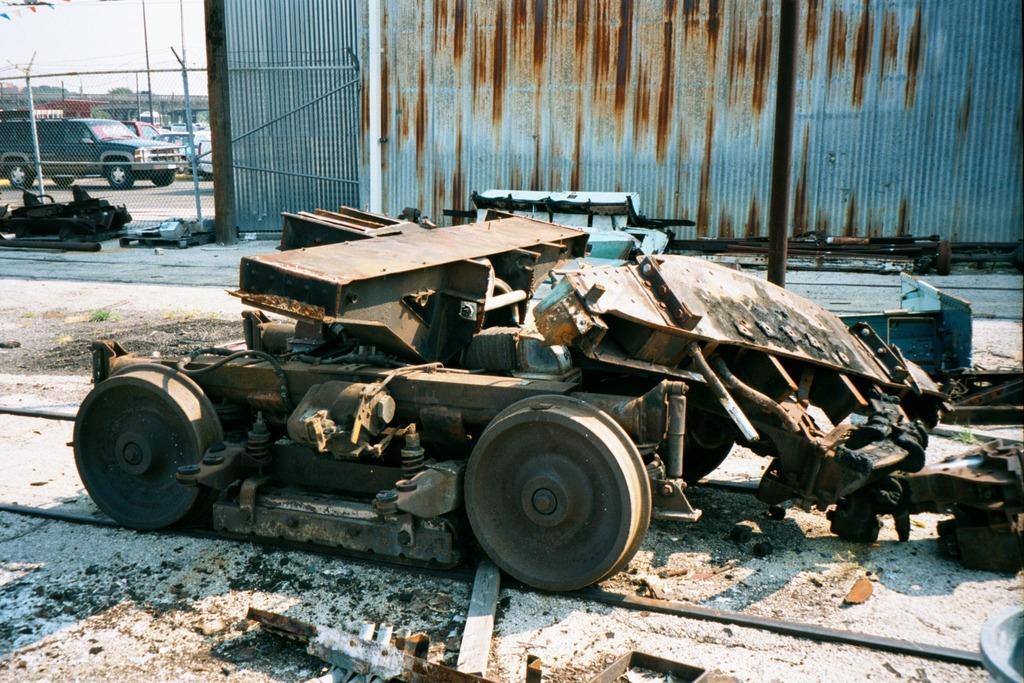Please provide a concise description of this image. In this picture we can see a vehicle and few objects on the ground and in the background we can see a fence, wall, few vehicles, trees and the sky. 